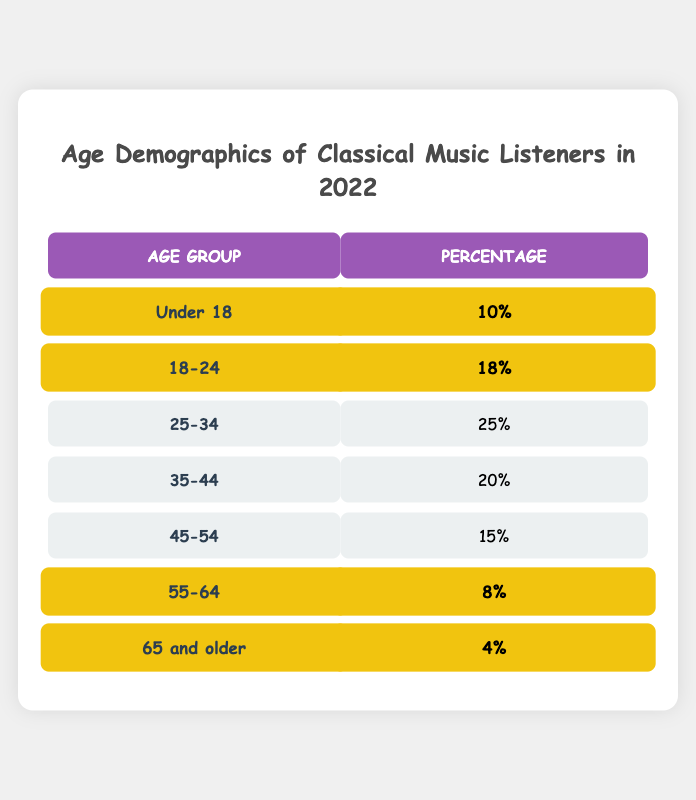What percentage of classical music listeners are aged 18-24? The table shows that the percentage for the age group 18-24 is 18.
Answer: 18% What is the total percentage of listeners aged 25-54? To find this, add the percentages for 25-34 (25), 35-44 (20), and 45-54 (15): 25 + 20 + 15 = 60.
Answer: 60% Is the percentage of listeners under 18 greater than the percentage of those aged 65 and older? Yes, the percentage of listeners under 18 is 10%, while the percentage for those aged 65 and older is 4%.
Answer: Yes What is the median age demographic percentage of classical music listeners? First, arrange the percentages in order: 4, 8, 10, 15, 18, 20, 25. There are seven values, so the median is the fourth value, which is 15.
Answer: 15% How many age groups have a percentage of 20 or more? From the table, age groups with 20 or more percent are: 25-34 (25) and 35-44 (20). Thus, there are 2 age groups.
Answer: 2 Which age group has the lowest percentage of classical music listeners? The age group 65 and older has the lowest percentage at 4%.
Answer: 65 and older What percentage of classical music listeners are 55 and older? Add the percentages for the age groups 55-64 (8) and 65 and older (4): 8 + 4 = 12.
Answer: 12% Is the age group 25-34 larger than age group 18-24 or not? Yes, the percentage of age group 25-34 is 25%, which is greater than 18% for age group 18-24.
Answer: Yes What percentage difference is there between listeners aged 35-44 and those aged 55-64? The difference is calculated by subtracting the two percentages: 20 (35-44) - 8 (55-64) = 12.
Answer: 12% What is the combined percentage of listeners below the age of 55? To find this, sum the percentages for age groups under 55: Under 18 (10) + 18-24 (18) + 25-34 (25) + 35-44 (20) + 45-54 (15) = 88.
Answer: 88% 